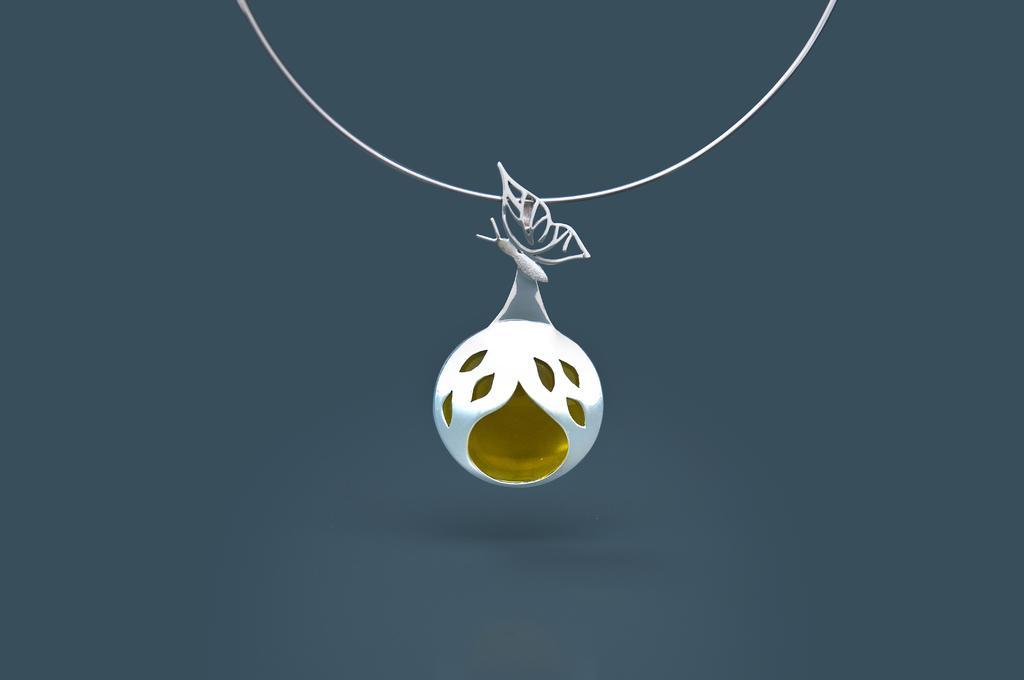In one or two sentences, can you explain what this image depicts? In this image there is a chain having a pendant having a butterfly structure on it. 